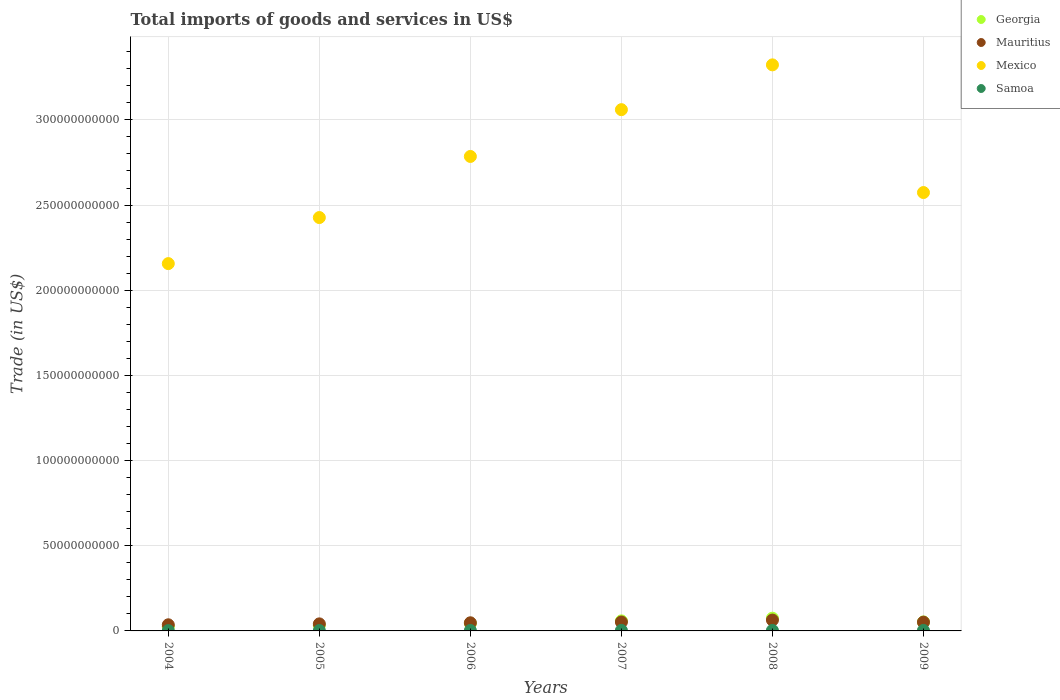Is the number of dotlines equal to the number of legend labels?
Keep it short and to the point. Yes. What is the total imports of goods and services in Samoa in 2005?
Give a very brief answer. 2.30e+08. Across all years, what is the maximum total imports of goods and services in Georgia?
Provide a short and direct response. 7.47e+09. Across all years, what is the minimum total imports of goods and services in Mexico?
Make the answer very short. 2.16e+11. In which year was the total imports of goods and services in Mauritius maximum?
Keep it short and to the point. 2008. In which year was the total imports of goods and services in Mauritius minimum?
Your answer should be very brief. 2004. What is the total total imports of goods and services in Mexico in the graph?
Offer a terse response. 1.63e+12. What is the difference between the total imports of goods and services in Georgia in 2004 and that in 2009?
Ensure brevity in your answer.  -2.80e+09. What is the difference between the total imports of goods and services in Mauritius in 2004 and the total imports of goods and services in Samoa in 2008?
Keep it short and to the point. 3.30e+09. What is the average total imports of goods and services in Mexico per year?
Provide a short and direct response. 2.72e+11. In the year 2009, what is the difference between the total imports of goods and services in Samoa and total imports of goods and services in Georgia?
Make the answer very short. -4.97e+09. What is the ratio of the total imports of goods and services in Mexico in 2006 to that in 2009?
Make the answer very short. 1.08. Is the total imports of goods and services in Mauritius in 2006 less than that in 2007?
Your answer should be very brief. Yes. What is the difference between the highest and the second highest total imports of goods and services in Georgia?
Ensure brevity in your answer.  1.58e+09. What is the difference between the highest and the lowest total imports of goods and services in Mexico?
Make the answer very short. 1.17e+11. Is it the case that in every year, the sum of the total imports of goods and services in Mexico and total imports of goods and services in Samoa  is greater than the sum of total imports of goods and services in Mauritius and total imports of goods and services in Georgia?
Provide a succinct answer. Yes. Is it the case that in every year, the sum of the total imports of goods and services in Mexico and total imports of goods and services in Samoa  is greater than the total imports of goods and services in Mauritius?
Provide a short and direct response. Yes. Is the total imports of goods and services in Mexico strictly greater than the total imports of goods and services in Georgia over the years?
Ensure brevity in your answer.  Yes. Are the values on the major ticks of Y-axis written in scientific E-notation?
Give a very brief answer. No. Does the graph contain grids?
Offer a terse response. Yes. How are the legend labels stacked?
Your response must be concise. Vertical. What is the title of the graph?
Ensure brevity in your answer.  Total imports of goods and services in US$. Does "Guyana" appear as one of the legend labels in the graph?
Your response must be concise. No. What is the label or title of the Y-axis?
Keep it short and to the point. Trade (in US$). What is the Trade (in US$) of Georgia in 2004?
Your answer should be very brief. 2.47e+09. What is the Trade (in US$) in Mauritius in 2004?
Your response must be concise. 3.60e+09. What is the Trade (in US$) of Mexico in 2004?
Offer a very short reply. 2.16e+11. What is the Trade (in US$) of Samoa in 2004?
Provide a succinct answer. 1.88e+08. What is the Trade (in US$) of Georgia in 2005?
Your answer should be very brief. 3.31e+09. What is the Trade (in US$) of Mauritius in 2005?
Your response must be concise. 4.14e+09. What is the Trade (in US$) in Mexico in 2005?
Your answer should be very brief. 2.43e+11. What is the Trade (in US$) of Samoa in 2005?
Offer a very short reply. 2.30e+08. What is the Trade (in US$) of Georgia in 2006?
Ensure brevity in your answer.  4.42e+09. What is the Trade (in US$) of Mauritius in 2006?
Ensure brevity in your answer.  4.78e+09. What is the Trade (in US$) in Mexico in 2006?
Keep it short and to the point. 2.79e+11. What is the Trade (in US$) of Samoa in 2006?
Your response must be concise. 2.66e+08. What is the Trade (in US$) in Georgia in 2007?
Offer a very short reply. 5.90e+09. What is the Trade (in US$) of Mauritius in 2007?
Your answer should be very brief. 5.23e+09. What is the Trade (in US$) of Mexico in 2007?
Give a very brief answer. 3.06e+11. What is the Trade (in US$) of Samoa in 2007?
Give a very brief answer. 3.13e+08. What is the Trade (in US$) of Georgia in 2008?
Your answer should be very brief. 7.47e+09. What is the Trade (in US$) in Mauritius in 2008?
Offer a terse response. 6.37e+09. What is the Trade (in US$) of Mexico in 2008?
Your response must be concise. 3.32e+11. What is the Trade (in US$) in Samoa in 2008?
Offer a very short reply. 2.97e+08. What is the Trade (in US$) in Georgia in 2009?
Offer a very short reply. 5.27e+09. What is the Trade (in US$) in Mauritius in 2009?
Keep it short and to the point. 5.15e+09. What is the Trade (in US$) of Mexico in 2009?
Your answer should be very brief. 2.57e+11. What is the Trade (in US$) in Samoa in 2009?
Your response must be concise. 3.03e+08. Across all years, what is the maximum Trade (in US$) of Georgia?
Ensure brevity in your answer.  7.47e+09. Across all years, what is the maximum Trade (in US$) in Mauritius?
Your answer should be very brief. 6.37e+09. Across all years, what is the maximum Trade (in US$) in Mexico?
Your response must be concise. 3.32e+11. Across all years, what is the maximum Trade (in US$) of Samoa?
Ensure brevity in your answer.  3.13e+08. Across all years, what is the minimum Trade (in US$) in Georgia?
Keep it short and to the point. 2.47e+09. Across all years, what is the minimum Trade (in US$) of Mauritius?
Ensure brevity in your answer.  3.60e+09. Across all years, what is the minimum Trade (in US$) of Mexico?
Give a very brief answer. 2.16e+11. Across all years, what is the minimum Trade (in US$) of Samoa?
Your answer should be compact. 1.88e+08. What is the total Trade (in US$) in Georgia in the graph?
Give a very brief answer. 2.88e+1. What is the total Trade (in US$) in Mauritius in the graph?
Provide a short and direct response. 2.93e+1. What is the total Trade (in US$) of Mexico in the graph?
Give a very brief answer. 1.63e+12. What is the total Trade (in US$) in Samoa in the graph?
Your response must be concise. 1.60e+09. What is the difference between the Trade (in US$) in Georgia in 2004 and that in 2005?
Offer a very short reply. -8.36e+08. What is the difference between the Trade (in US$) in Mauritius in 2004 and that in 2005?
Your answer should be compact. -5.37e+08. What is the difference between the Trade (in US$) in Mexico in 2004 and that in 2005?
Offer a very short reply. -2.70e+1. What is the difference between the Trade (in US$) in Samoa in 2004 and that in 2005?
Your response must be concise. -4.20e+07. What is the difference between the Trade (in US$) in Georgia in 2004 and that in 2006?
Your response must be concise. -1.95e+09. What is the difference between the Trade (in US$) of Mauritius in 2004 and that in 2006?
Ensure brevity in your answer.  -1.17e+09. What is the difference between the Trade (in US$) in Mexico in 2004 and that in 2006?
Provide a short and direct response. -6.29e+1. What is the difference between the Trade (in US$) of Samoa in 2004 and that in 2006?
Keep it short and to the point. -7.80e+07. What is the difference between the Trade (in US$) in Georgia in 2004 and that in 2007?
Provide a succinct answer. -3.43e+09. What is the difference between the Trade (in US$) of Mauritius in 2004 and that in 2007?
Your response must be concise. -1.63e+09. What is the difference between the Trade (in US$) in Mexico in 2004 and that in 2007?
Provide a short and direct response. -9.04e+1. What is the difference between the Trade (in US$) of Samoa in 2004 and that in 2007?
Provide a short and direct response. -1.25e+08. What is the difference between the Trade (in US$) in Georgia in 2004 and that in 2008?
Ensure brevity in your answer.  -5.00e+09. What is the difference between the Trade (in US$) of Mauritius in 2004 and that in 2008?
Your answer should be compact. -2.77e+09. What is the difference between the Trade (in US$) in Mexico in 2004 and that in 2008?
Your answer should be compact. -1.17e+11. What is the difference between the Trade (in US$) in Samoa in 2004 and that in 2008?
Offer a terse response. -1.09e+08. What is the difference between the Trade (in US$) of Georgia in 2004 and that in 2009?
Ensure brevity in your answer.  -2.80e+09. What is the difference between the Trade (in US$) in Mauritius in 2004 and that in 2009?
Keep it short and to the point. -1.55e+09. What is the difference between the Trade (in US$) of Mexico in 2004 and that in 2009?
Keep it short and to the point. -4.17e+1. What is the difference between the Trade (in US$) of Samoa in 2004 and that in 2009?
Ensure brevity in your answer.  -1.16e+08. What is the difference between the Trade (in US$) of Georgia in 2005 and that in 2006?
Keep it short and to the point. -1.11e+09. What is the difference between the Trade (in US$) in Mauritius in 2005 and that in 2006?
Your answer should be very brief. -6.37e+08. What is the difference between the Trade (in US$) of Mexico in 2005 and that in 2006?
Your answer should be compact. -3.59e+1. What is the difference between the Trade (in US$) in Samoa in 2005 and that in 2006?
Provide a succinct answer. -3.60e+07. What is the difference between the Trade (in US$) in Georgia in 2005 and that in 2007?
Ensure brevity in your answer.  -2.59e+09. What is the difference between the Trade (in US$) in Mauritius in 2005 and that in 2007?
Give a very brief answer. -1.10e+09. What is the difference between the Trade (in US$) in Mexico in 2005 and that in 2007?
Offer a terse response. -6.33e+1. What is the difference between the Trade (in US$) of Samoa in 2005 and that in 2007?
Provide a succinct answer. -8.33e+07. What is the difference between the Trade (in US$) in Georgia in 2005 and that in 2008?
Provide a short and direct response. -4.17e+09. What is the difference between the Trade (in US$) in Mauritius in 2005 and that in 2008?
Give a very brief answer. -2.23e+09. What is the difference between the Trade (in US$) in Mexico in 2005 and that in 2008?
Offer a terse response. -8.96e+1. What is the difference between the Trade (in US$) in Samoa in 2005 and that in 2008?
Provide a succinct answer. -6.72e+07. What is the difference between the Trade (in US$) in Georgia in 2005 and that in 2009?
Your answer should be very brief. -1.96e+09. What is the difference between the Trade (in US$) in Mauritius in 2005 and that in 2009?
Offer a terse response. -1.01e+09. What is the difference between the Trade (in US$) in Mexico in 2005 and that in 2009?
Make the answer very short. -1.47e+1. What is the difference between the Trade (in US$) in Samoa in 2005 and that in 2009?
Give a very brief answer. -7.36e+07. What is the difference between the Trade (in US$) of Georgia in 2006 and that in 2007?
Give a very brief answer. -1.48e+09. What is the difference between the Trade (in US$) of Mauritius in 2006 and that in 2007?
Your answer should be compact. -4.58e+08. What is the difference between the Trade (in US$) of Mexico in 2006 and that in 2007?
Ensure brevity in your answer.  -2.75e+1. What is the difference between the Trade (in US$) in Samoa in 2006 and that in 2007?
Keep it short and to the point. -4.74e+07. What is the difference between the Trade (in US$) in Georgia in 2006 and that in 2008?
Make the answer very short. -3.06e+09. What is the difference between the Trade (in US$) in Mauritius in 2006 and that in 2008?
Ensure brevity in your answer.  -1.60e+09. What is the difference between the Trade (in US$) of Mexico in 2006 and that in 2008?
Offer a very short reply. -5.38e+1. What is the difference between the Trade (in US$) of Samoa in 2006 and that in 2008?
Ensure brevity in your answer.  -3.12e+07. What is the difference between the Trade (in US$) in Georgia in 2006 and that in 2009?
Offer a terse response. -8.52e+08. What is the difference between the Trade (in US$) of Mauritius in 2006 and that in 2009?
Your answer should be compact. -3.76e+08. What is the difference between the Trade (in US$) of Mexico in 2006 and that in 2009?
Give a very brief answer. 2.12e+1. What is the difference between the Trade (in US$) in Samoa in 2006 and that in 2009?
Your response must be concise. -3.76e+07. What is the difference between the Trade (in US$) of Georgia in 2007 and that in 2008?
Make the answer very short. -1.58e+09. What is the difference between the Trade (in US$) in Mauritius in 2007 and that in 2008?
Offer a terse response. -1.14e+09. What is the difference between the Trade (in US$) in Mexico in 2007 and that in 2008?
Make the answer very short. -2.63e+1. What is the difference between the Trade (in US$) in Samoa in 2007 and that in 2008?
Your answer should be compact. 1.61e+07. What is the difference between the Trade (in US$) in Georgia in 2007 and that in 2009?
Offer a very short reply. 6.27e+08. What is the difference between the Trade (in US$) in Mauritius in 2007 and that in 2009?
Offer a very short reply. 8.21e+07. What is the difference between the Trade (in US$) of Mexico in 2007 and that in 2009?
Provide a short and direct response. 4.87e+1. What is the difference between the Trade (in US$) in Samoa in 2007 and that in 2009?
Your response must be concise. 9.73e+06. What is the difference between the Trade (in US$) of Georgia in 2008 and that in 2009?
Provide a short and direct response. 2.20e+09. What is the difference between the Trade (in US$) of Mauritius in 2008 and that in 2009?
Offer a terse response. 1.22e+09. What is the difference between the Trade (in US$) in Mexico in 2008 and that in 2009?
Give a very brief answer. 7.49e+1. What is the difference between the Trade (in US$) in Samoa in 2008 and that in 2009?
Your answer should be very brief. -6.39e+06. What is the difference between the Trade (in US$) in Georgia in 2004 and the Trade (in US$) in Mauritius in 2005?
Offer a very short reply. -1.67e+09. What is the difference between the Trade (in US$) in Georgia in 2004 and the Trade (in US$) in Mexico in 2005?
Make the answer very short. -2.40e+11. What is the difference between the Trade (in US$) of Georgia in 2004 and the Trade (in US$) of Samoa in 2005?
Give a very brief answer. 2.24e+09. What is the difference between the Trade (in US$) of Mauritius in 2004 and the Trade (in US$) of Mexico in 2005?
Make the answer very short. -2.39e+11. What is the difference between the Trade (in US$) of Mauritius in 2004 and the Trade (in US$) of Samoa in 2005?
Provide a short and direct response. 3.37e+09. What is the difference between the Trade (in US$) in Mexico in 2004 and the Trade (in US$) in Samoa in 2005?
Your answer should be compact. 2.15e+11. What is the difference between the Trade (in US$) of Georgia in 2004 and the Trade (in US$) of Mauritius in 2006?
Your answer should be very brief. -2.31e+09. What is the difference between the Trade (in US$) in Georgia in 2004 and the Trade (in US$) in Mexico in 2006?
Your answer should be very brief. -2.76e+11. What is the difference between the Trade (in US$) in Georgia in 2004 and the Trade (in US$) in Samoa in 2006?
Your answer should be compact. 2.20e+09. What is the difference between the Trade (in US$) of Mauritius in 2004 and the Trade (in US$) of Mexico in 2006?
Give a very brief answer. -2.75e+11. What is the difference between the Trade (in US$) in Mauritius in 2004 and the Trade (in US$) in Samoa in 2006?
Make the answer very short. 3.34e+09. What is the difference between the Trade (in US$) of Mexico in 2004 and the Trade (in US$) of Samoa in 2006?
Your answer should be compact. 2.15e+11. What is the difference between the Trade (in US$) in Georgia in 2004 and the Trade (in US$) in Mauritius in 2007?
Your response must be concise. -2.76e+09. What is the difference between the Trade (in US$) of Georgia in 2004 and the Trade (in US$) of Mexico in 2007?
Your answer should be compact. -3.04e+11. What is the difference between the Trade (in US$) in Georgia in 2004 and the Trade (in US$) in Samoa in 2007?
Make the answer very short. 2.16e+09. What is the difference between the Trade (in US$) of Mauritius in 2004 and the Trade (in US$) of Mexico in 2007?
Offer a terse response. -3.02e+11. What is the difference between the Trade (in US$) in Mauritius in 2004 and the Trade (in US$) in Samoa in 2007?
Provide a short and direct response. 3.29e+09. What is the difference between the Trade (in US$) in Mexico in 2004 and the Trade (in US$) in Samoa in 2007?
Offer a terse response. 2.15e+11. What is the difference between the Trade (in US$) in Georgia in 2004 and the Trade (in US$) in Mauritius in 2008?
Give a very brief answer. -3.90e+09. What is the difference between the Trade (in US$) in Georgia in 2004 and the Trade (in US$) in Mexico in 2008?
Keep it short and to the point. -3.30e+11. What is the difference between the Trade (in US$) of Georgia in 2004 and the Trade (in US$) of Samoa in 2008?
Provide a succinct answer. 2.17e+09. What is the difference between the Trade (in US$) in Mauritius in 2004 and the Trade (in US$) in Mexico in 2008?
Keep it short and to the point. -3.29e+11. What is the difference between the Trade (in US$) of Mauritius in 2004 and the Trade (in US$) of Samoa in 2008?
Offer a very short reply. 3.30e+09. What is the difference between the Trade (in US$) in Mexico in 2004 and the Trade (in US$) in Samoa in 2008?
Offer a very short reply. 2.15e+11. What is the difference between the Trade (in US$) in Georgia in 2004 and the Trade (in US$) in Mauritius in 2009?
Make the answer very short. -2.68e+09. What is the difference between the Trade (in US$) in Georgia in 2004 and the Trade (in US$) in Mexico in 2009?
Give a very brief answer. -2.55e+11. What is the difference between the Trade (in US$) of Georgia in 2004 and the Trade (in US$) of Samoa in 2009?
Provide a short and direct response. 2.17e+09. What is the difference between the Trade (in US$) in Mauritius in 2004 and the Trade (in US$) in Mexico in 2009?
Ensure brevity in your answer.  -2.54e+11. What is the difference between the Trade (in US$) in Mauritius in 2004 and the Trade (in US$) in Samoa in 2009?
Offer a terse response. 3.30e+09. What is the difference between the Trade (in US$) in Mexico in 2004 and the Trade (in US$) in Samoa in 2009?
Offer a terse response. 2.15e+11. What is the difference between the Trade (in US$) in Georgia in 2005 and the Trade (in US$) in Mauritius in 2006?
Offer a terse response. -1.47e+09. What is the difference between the Trade (in US$) in Georgia in 2005 and the Trade (in US$) in Mexico in 2006?
Offer a terse response. -2.75e+11. What is the difference between the Trade (in US$) of Georgia in 2005 and the Trade (in US$) of Samoa in 2006?
Ensure brevity in your answer.  3.04e+09. What is the difference between the Trade (in US$) in Mauritius in 2005 and the Trade (in US$) in Mexico in 2006?
Keep it short and to the point. -2.74e+11. What is the difference between the Trade (in US$) of Mauritius in 2005 and the Trade (in US$) of Samoa in 2006?
Keep it short and to the point. 3.87e+09. What is the difference between the Trade (in US$) in Mexico in 2005 and the Trade (in US$) in Samoa in 2006?
Ensure brevity in your answer.  2.42e+11. What is the difference between the Trade (in US$) of Georgia in 2005 and the Trade (in US$) of Mauritius in 2007?
Make the answer very short. -1.93e+09. What is the difference between the Trade (in US$) of Georgia in 2005 and the Trade (in US$) of Mexico in 2007?
Provide a short and direct response. -3.03e+11. What is the difference between the Trade (in US$) in Georgia in 2005 and the Trade (in US$) in Samoa in 2007?
Offer a very short reply. 2.99e+09. What is the difference between the Trade (in US$) in Mauritius in 2005 and the Trade (in US$) in Mexico in 2007?
Give a very brief answer. -3.02e+11. What is the difference between the Trade (in US$) of Mauritius in 2005 and the Trade (in US$) of Samoa in 2007?
Your answer should be very brief. 3.83e+09. What is the difference between the Trade (in US$) in Mexico in 2005 and the Trade (in US$) in Samoa in 2007?
Keep it short and to the point. 2.42e+11. What is the difference between the Trade (in US$) of Georgia in 2005 and the Trade (in US$) of Mauritius in 2008?
Provide a short and direct response. -3.07e+09. What is the difference between the Trade (in US$) of Georgia in 2005 and the Trade (in US$) of Mexico in 2008?
Make the answer very short. -3.29e+11. What is the difference between the Trade (in US$) in Georgia in 2005 and the Trade (in US$) in Samoa in 2008?
Offer a terse response. 3.01e+09. What is the difference between the Trade (in US$) of Mauritius in 2005 and the Trade (in US$) of Mexico in 2008?
Give a very brief answer. -3.28e+11. What is the difference between the Trade (in US$) in Mauritius in 2005 and the Trade (in US$) in Samoa in 2008?
Provide a short and direct response. 3.84e+09. What is the difference between the Trade (in US$) in Mexico in 2005 and the Trade (in US$) in Samoa in 2008?
Your answer should be very brief. 2.42e+11. What is the difference between the Trade (in US$) of Georgia in 2005 and the Trade (in US$) of Mauritius in 2009?
Provide a succinct answer. -1.85e+09. What is the difference between the Trade (in US$) of Georgia in 2005 and the Trade (in US$) of Mexico in 2009?
Make the answer very short. -2.54e+11. What is the difference between the Trade (in US$) in Georgia in 2005 and the Trade (in US$) in Samoa in 2009?
Ensure brevity in your answer.  3.00e+09. What is the difference between the Trade (in US$) in Mauritius in 2005 and the Trade (in US$) in Mexico in 2009?
Your answer should be very brief. -2.53e+11. What is the difference between the Trade (in US$) in Mauritius in 2005 and the Trade (in US$) in Samoa in 2009?
Your answer should be compact. 3.83e+09. What is the difference between the Trade (in US$) in Mexico in 2005 and the Trade (in US$) in Samoa in 2009?
Provide a short and direct response. 2.42e+11. What is the difference between the Trade (in US$) of Georgia in 2006 and the Trade (in US$) of Mauritius in 2007?
Provide a succinct answer. -8.18e+08. What is the difference between the Trade (in US$) of Georgia in 2006 and the Trade (in US$) of Mexico in 2007?
Ensure brevity in your answer.  -3.02e+11. What is the difference between the Trade (in US$) in Georgia in 2006 and the Trade (in US$) in Samoa in 2007?
Your answer should be very brief. 4.10e+09. What is the difference between the Trade (in US$) of Mauritius in 2006 and the Trade (in US$) of Mexico in 2007?
Ensure brevity in your answer.  -3.01e+11. What is the difference between the Trade (in US$) in Mauritius in 2006 and the Trade (in US$) in Samoa in 2007?
Your answer should be very brief. 4.46e+09. What is the difference between the Trade (in US$) of Mexico in 2006 and the Trade (in US$) of Samoa in 2007?
Ensure brevity in your answer.  2.78e+11. What is the difference between the Trade (in US$) of Georgia in 2006 and the Trade (in US$) of Mauritius in 2008?
Your answer should be very brief. -1.96e+09. What is the difference between the Trade (in US$) of Georgia in 2006 and the Trade (in US$) of Mexico in 2008?
Offer a very short reply. -3.28e+11. What is the difference between the Trade (in US$) of Georgia in 2006 and the Trade (in US$) of Samoa in 2008?
Give a very brief answer. 4.12e+09. What is the difference between the Trade (in US$) of Mauritius in 2006 and the Trade (in US$) of Mexico in 2008?
Offer a terse response. -3.28e+11. What is the difference between the Trade (in US$) of Mauritius in 2006 and the Trade (in US$) of Samoa in 2008?
Provide a short and direct response. 4.48e+09. What is the difference between the Trade (in US$) of Mexico in 2006 and the Trade (in US$) of Samoa in 2008?
Offer a terse response. 2.78e+11. What is the difference between the Trade (in US$) in Georgia in 2006 and the Trade (in US$) in Mauritius in 2009?
Provide a succinct answer. -7.36e+08. What is the difference between the Trade (in US$) of Georgia in 2006 and the Trade (in US$) of Mexico in 2009?
Offer a terse response. -2.53e+11. What is the difference between the Trade (in US$) in Georgia in 2006 and the Trade (in US$) in Samoa in 2009?
Provide a short and direct response. 4.11e+09. What is the difference between the Trade (in US$) in Mauritius in 2006 and the Trade (in US$) in Mexico in 2009?
Offer a terse response. -2.53e+11. What is the difference between the Trade (in US$) in Mauritius in 2006 and the Trade (in US$) in Samoa in 2009?
Ensure brevity in your answer.  4.47e+09. What is the difference between the Trade (in US$) in Mexico in 2006 and the Trade (in US$) in Samoa in 2009?
Your answer should be very brief. 2.78e+11. What is the difference between the Trade (in US$) in Georgia in 2007 and the Trade (in US$) in Mauritius in 2008?
Make the answer very short. -4.77e+08. What is the difference between the Trade (in US$) of Georgia in 2007 and the Trade (in US$) of Mexico in 2008?
Offer a terse response. -3.26e+11. What is the difference between the Trade (in US$) in Georgia in 2007 and the Trade (in US$) in Samoa in 2008?
Give a very brief answer. 5.60e+09. What is the difference between the Trade (in US$) in Mauritius in 2007 and the Trade (in US$) in Mexico in 2008?
Give a very brief answer. -3.27e+11. What is the difference between the Trade (in US$) of Mauritius in 2007 and the Trade (in US$) of Samoa in 2008?
Offer a very short reply. 4.94e+09. What is the difference between the Trade (in US$) in Mexico in 2007 and the Trade (in US$) in Samoa in 2008?
Make the answer very short. 3.06e+11. What is the difference between the Trade (in US$) in Georgia in 2007 and the Trade (in US$) in Mauritius in 2009?
Your answer should be compact. 7.43e+08. What is the difference between the Trade (in US$) in Georgia in 2007 and the Trade (in US$) in Mexico in 2009?
Provide a succinct answer. -2.51e+11. What is the difference between the Trade (in US$) in Georgia in 2007 and the Trade (in US$) in Samoa in 2009?
Make the answer very short. 5.59e+09. What is the difference between the Trade (in US$) of Mauritius in 2007 and the Trade (in US$) of Mexico in 2009?
Your response must be concise. -2.52e+11. What is the difference between the Trade (in US$) in Mauritius in 2007 and the Trade (in US$) in Samoa in 2009?
Your answer should be compact. 4.93e+09. What is the difference between the Trade (in US$) in Mexico in 2007 and the Trade (in US$) in Samoa in 2009?
Provide a short and direct response. 3.06e+11. What is the difference between the Trade (in US$) in Georgia in 2008 and the Trade (in US$) in Mauritius in 2009?
Offer a very short reply. 2.32e+09. What is the difference between the Trade (in US$) in Georgia in 2008 and the Trade (in US$) in Mexico in 2009?
Give a very brief answer. -2.50e+11. What is the difference between the Trade (in US$) of Georgia in 2008 and the Trade (in US$) of Samoa in 2009?
Provide a succinct answer. 7.17e+09. What is the difference between the Trade (in US$) in Mauritius in 2008 and the Trade (in US$) in Mexico in 2009?
Keep it short and to the point. -2.51e+11. What is the difference between the Trade (in US$) of Mauritius in 2008 and the Trade (in US$) of Samoa in 2009?
Keep it short and to the point. 6.07e+09. What is the difference between the Trade (in US$) of Mexico in 2008 and the Trade (in US$) of Samoa in 2009?
Provide a short and direct response. 3.32e+11. What is the average Trade (in US$) in Georgia per year?
Ensure brevity in your answer.  4.80e+09. What is the average Trade (in US$) in Mauritius per year?
Keep it short and to the point. 4.88e+09. What is the average Trade (in US$) in Mexico per year?
Provide a succinct answer. 2.72e+11. What is the average Trade (in US$) in Samoa per year?
Offer a very short reply. 2.66e+08. In the year 2004, what is the difference between the Trade (in US$) in Georgia and Trade (in US$) in Mauritius?
Keep it short and to the point. -1.13e+09. In the year 2004, what is the difference between the Trade (in US$) in Georgia and Trade (in US$) in Mexico?
Offer a terse response. -2.13e+11. In the year 2004, what is the difference between the Trade (in US$) in Georgia and Trade (in US$) in Samoa?
Keep it short and to the point. 2.28e+09. In the year 2004, what is the difference between the Trade (in US$) of Mauritius and Trade (in US$) of Mexico?
Give a very brief answer. -2.12e+11. In the year 2004, what is the difference between the Trade (in US$) in Mauritius and Trade (in US$) in Samoa?
Offer a terse response. 3.41e+09. In the year 2004, what is the difference between the Trade (in US$) of Mexico and Trade (in US$) of Samoa?
Offer a very short reply. 2.15e+11. In the year 2005, what is the difference between the Trade (in US$) in Georgia and Trade (in US$) in Mauritius?
Make the answer very short. -8.32e+08. In the year 2005, what is the difference between the Trade (in US$) of Georgia and Trade (in US$) of Mexico?
Give a very brief answer. -2.39e+11. In the year 2005, what is the difference between the Trade (in US$) of Georgia and Trade (in US$) of Samoa?
Offer a terse response. 3.08e+09. In the year 2005, what is the difference between the Trade (in US$) of Mauritius and Trade (in US$) of Mexico?
Your response must be concise. -2.39e+11. In the year 2005, what is the difference between the Trade (in US$) of Mauritius and Trade (in US$) of Samoa?
Give a very brief answer. 3.91e+09. In the year 2005, what is the difference between the Trade (in US$) in Mexico and Trade (in US$) in Samoa?
Keep it short and to the point. 2.42e+11. In the year 2006, what is the difference between the Trade (in US$) in Georgia and Trade (in US$) in Mauritius?
Offer a terse response. -3.60e+08. In the year 2006, what is the difference between the Trade (in US$) in Georgia and Trade (in US$) in Mexico?
Keep it short and to the point. -2.74e+11. In the year 2006, what is the difference between the Trade (in US$) of Georgia and Trade (in US$) of Samoa?
Give a very brief answer. 4.15e+09. In the year 2006, what is the difference between the Trade (in US$) in Mauritius and Trade (in US$) in Mexico?
Provide a succinct answer. -2.74e+11. In the year 2006, what is the difference between the Trade (in US$) of Mauritius and Trade (in US$) of Samoa?
Your response must be concise. 4.51e+09. In the year 2006, what is the difference between the Trade (in US$) in Mexico and Trade (in US$) in Samoa?
Give a very brief answer. 2.78e+11. In the year 2007, what is the difference between the Trade (in US$) in Georgia and Trade (in US$) in Mauritius?
Make the answer very short. 6.61e+08. In the year 2007, what is the difference between the Trade (in US$) in Georgia and Trade (in US$) in Mexico?
Provide a short and direct response. -3.00e+11. In the year 2007, what is the difference between the Trade (in US$) in Georgia and Trade (in US$) in Samoa?
Provide a succinct answer. 5.58e+09. In the year 2007, what is the difference between the Trade (in US$) of Mauritius and Trade (in US$) of Mexico?
Your answer should be compact. -3.01e+11. In the year 2007, what is the difference between the Trade (in US$) of Mauritius and Trade (in US$) of Samoa?
Keep it short and to the point. 4.92e+09. In the year 2007, what is the difference between the Trade (in US$) of Mexico and Trade (in US$) of Samoa?
Provide a short and direct response. 3.06e+11. In the year 2008, what is the difference between the Trade (in US$) in Georgia and Trade (in US$) in Mauritius?
Offer a terse response. 1.10e+09. In the year 2008, what is the difference between the Trade (in US$) in Georgia and Trade (in US$) in Mexico?
Your response must be concise. -3.25e+11. In the year 2008, what is the difference between the Trade (in US$) in Georgia and Trade (in US$) in Samoa?
Make the answer very short. 7.18e+09. In the year 2008, what is the difference between the Trade (in US$) of Mauritius and Trade (in US$) of Mexico?
Make the answer very short. -3.26e+11. In the year 2008, what is the difference between the Trade (in US$) of Mauritius and Trade (in US$) of Samoa?
Provide a short and direct response. 6.08e+09. In the year 2008, what is the difference between the Trade (in US$) in Mexico and Trade (in US$) in Samoa?
Offer a terse response. 3.32e+11. In the year 2009, what is the difference between the Trade (in US$) of Georgia and Trade (in US$) of Mauritius?
Offer a terse response. 1.17e+08. In the year 2009, what is the difference between the Trade (in US$) of Georgia and Trade (in US$) of Mexico?
Keep it short and to the point. -2.52e+11. In the year 2009, what is the difference between the Trade (in US$) of Georgia and Trade (in US$) of Samoa?
Your answer should be compact. 4.97e+09. In the year 2009, what is the difference between the Trade (in US$) in Mauritius and Trade (in US$) in Mexico?
Make the answer very short. -2.52e+11. In the year 2009, what is the difference between the Trade (in US$) of Mauritius and Trade (in US$) of Samoa?
Provide a short and direct response. 4.85e+09. In the year 2009, what is the difference between the Trade (in US$) in Mexico and Trade (in US$) in Samoa?
Your response must be concise. 2.57e+11. What is the ratio of the Trade (in US$) of Georgia in 2004 to that in 2005?
Provide a succinct answer. 0.75. What is the ratio of the Trade (in US$) of Mauritius in 2004 to that in 2005?
Ensure brevity in your answer.  0.87. What is the ratio of the Trade (in US$) in Mexico in 2004 to that in 2005?
Give a very brief answer. 0.89. What is the ratio of the Trade (in US$) in Samoa in 2004 to that in 2005?
Provide a succinct answer. 0.82. What is the ratio of the Trade (in US$) of Georgia in 2004 to that in 2006?
Give a very brief answer. 0.56. What is the ratio of the Trade (in US$) of Mauritius in 2004 to that in 2006?
Your response must be concise. 0.75. What is the ratio of the Trade (in US$) in Mexico in 2004 to that in 2006?
Ensure brevity in your answer.  0.77. What is the ratio of the Trade (in US$) in Samoa in 2004 to that in 2006?
Offer a terse response. 0.71. What is the ratio of the Trade (in US$) in Georgia in 2004 to that in 2007?
Offer a terse response. 0.42. What is the ratio of the Trade (in US$) of Mauritius in 2004 to that in 2007?
Make the answer very short. 0.69. What is the ratio of the Trade (in US$) in Mexico in 2004 to that in 2007?
Provide a succinct answer. 0.7. What is the ratio of the Trade (in US$) in Samoa in 2004 to that in 2007?
Your response must be concise. 0.6. What is the ratio of the Trade (in US$) of Georgia in 2004 to that in 2008?
Keep it short and to the point. 0.33. What is the ratio of the Trade (in US$) in Mauritius in 2004 to that in 2008?
Ensure brevity in your answer.  0.57. What is the ratio of the Trade (in US$) in Mexico in 2004 to that in 2008?
Provide a succinct answer. 0.65. What is the ratio of the Trade (in US$) of Samoa in 2004 to that in 2008?
Offer a terse response. 0.63. What is the ratio of the Trade (in US$) of Georgia in 2004 to that in 2009?
Keep it short and to the point. 0.47. What is the ratio of the Trade (in US$) of Mauritius in 2004 to that in 2009?
Ensure brevity in your answer.  0.7. What is the ratio of the Trade (in US$) in Mexico in 2004 to that in 2009?
Ensure brevity in your answer.  0.84. What is the ratio of the Trade (in US$) of Samoa in 2004 to that in 2009?
Offer a very short reply. 0.62. What is the ratio of the Trade (in US$) in Georgia in 2005 to that in 2006?
Your answer should be very brief. 0.75. What is the ratio of the Trade (in US$) in Mauritius in 2005 to that in 2006?
Make the answer very short. 0.87. What is the ratio of the Trade (in US$) in Mexico in 2005 to that in 2006?
Keep it short and to the point. 0.87. What is the ratio of the Trade (in US$) of Samoa in 2005 to that in 2006?
Ensure brevity in your answer.  0.86. What is the ratio of the Trade (in US$) of Georgia in 2005 to that in 2007?
Provide a succinct answer. 0.56. What is the ratio of the Trade (in US$) of Mauritius in 2005 to that in 2007?
Your answer should be very brief. 0.79. What is the ratio of the Trade (in US$) in Mexico in 2005 to that in 2007?
Ensure brevity in your answer.  0.79. What is the ratio of the Trade (in US$) in Samoa in 2005 to that in 2007?
Keep it short and to the point. 0.73. What is the ratio of the Trade (in US$) of Georgia in 2005 to that in 2008?
Offer a very short reply. 0.44. What is the ratio of the Trade (in US$) of Mauritius in 2005 to that in 2008?
Make the answer very short. 0.65. What is the ratio of the Trade (in US$) of Mexico in 2005 to that in 2008?
Your answer should be compact. 0.73. What is the ratio of the Trade (in US$) in Samoa in 2005 to that in 2008?
Offer a very short reply. 0.77. What is the ratio of the Trade (in US$) in Georgia in 2005 to that in 2009?
Provide a short and direct response. 0.63. What is the ratio of the Trade (in US$) in Mauritius in 2005 to that in 2009?
Ensure brevity in your answer.  0.8. What is the ratio of the Trade (in US$) of Mexico in 2005 to that in 2009?
Make the answer very short. 0.94. What is the ratio of the Trade (in US$) in Samoa in 2005 to that in 2009?
Give a very brief answer. 0.76. What is the ratio of the Trade (in US$) of Georgia in 2006 to that in 2007?
Provide a short and direct response. 0.75. What is the ratio of the Trade (in US$) in Mauritius in 2006 to that in 2007?
Your answer should be compact. 0.91. What is the ratio of the Trade (in US$) of Mexico in 2006 to that in 2007?
Offer a terse response. 0.91. What is the ratio of the Trade (in US$) of Samoa in 2006 to that in 2007?
Provide a short and direct response. 0.85. What is the ratio of the Trade (in US$) of Georgia in 2006 to that in 2008?
Your answer should be compact. 0.59. What is the ratio of the Trade (in US$) in Mauritius in 2006 to that in 2008?
Offer a very short reply. 0.75. What is the ratio of the Trade (in US$) of Mexico in 2006 to that in 2008?
Your answer should be compact. 0.84. What is the ratio of the Trade (in US$) of Samoa in 2006 to that in 2008?
Give a very brief answer. 0.89. What is the ratio of the Trade (in US$) in Georgia in 2006 to that in 2009?
Give a very brief answer. 0.84. What is the ratio of the Trade (in US$) of Mauritius in 2006 to that in 2009?
Your response must be concise. 0.93. What is the ratio of the Trade (in US$) in Mexico in 2006 to that in 2009?
Offer a terse response. 1.08. What is the ratio of the Trade (in US$) in Samoa in 2006 to that in 2009?
Give a very brief answer. 0.88. What is the ratio of the Trade (in US$) of Georgia in 2007 to that in 2008?
Provide a short and direct response. 0.79. What is the ratio of the Trade (in US$) of Mauritius in 2007 to that in 2008?
Keep it short and to the point. 0.82. What is the ratio of the Trade (in US$) of Mexico in 2007 to that in 2008?
Provide a short and direct response. 0.92. What is the ratio of the Trade (in US$) in Samoa in 2007 to that in 2008?
Offer a very short reply. 1.05. What is the ratio of the Trade (in US$) of Georgia in 2007 to that in 2009?
Make the answer very short. 1.12. What is the ratio of the Trade (in US$) of Mauritius in 2007 to that in 2009?
Make the answer very short. 1.02. What is the ratio of the Trade (in US$) in Mexico in 2007 to that in 2009?
Your response must be concise. 1.19. What is the ratio of the Trade (in US$) of Samoa in 2007 to that in 2009?
Provide a succinct answer. 1.03. What is the ratio of the Trade (in US$) of Georgia in 2008 to that in 2009?
Ensure brevity in your answer.  1.42. What is the ratio of the Trade (in US$) of Mauritius in 2008 to that in 2009?
Give a very brief answer. 1.24. What is the ratio of the Trade (in US$) in Mexico in 2008 to that in 2009?
Your answer should be very brief. 1.29. What is the ratio of the Trade (in US$) of Samoa in 2008 to that in 2009?
Your answer should be very brief. 0.98. What is the difference between the highest and the second highest Trade (in US$) in Georgia?
Provide a short and direct response. 1.58e+09. What is the difference between the highest and the second highest Trade (in US$) of Mauritius?
Give a very brief answer. 1.14e+09. What is the difference between the highest and the second highest Trade (in US$) of Mexico?
Provide a succinct answer. 2.63e+1. What is the difference between the highest and the second highest Trade (in US$) of Samoa?
Provide a succinct answer. 9.73e+06. What is the difference between the highest and the lowest Trade (in US$) of Georgia?
Offer a very short reply. 5.00e+09. What is the difference between the highest and the lowest Trade (in US$) of Mauritius?
Provide a succinct answer. 2.77e+09. What is the difference between the highest and the lowest Trade (in US$) in Mexico?
Provide a short and direct response. 1.17e+11. What is the difference between the highest and the lowest Trade (in US$) in Samoa?
Your response must be concise. 1.25e+08. 